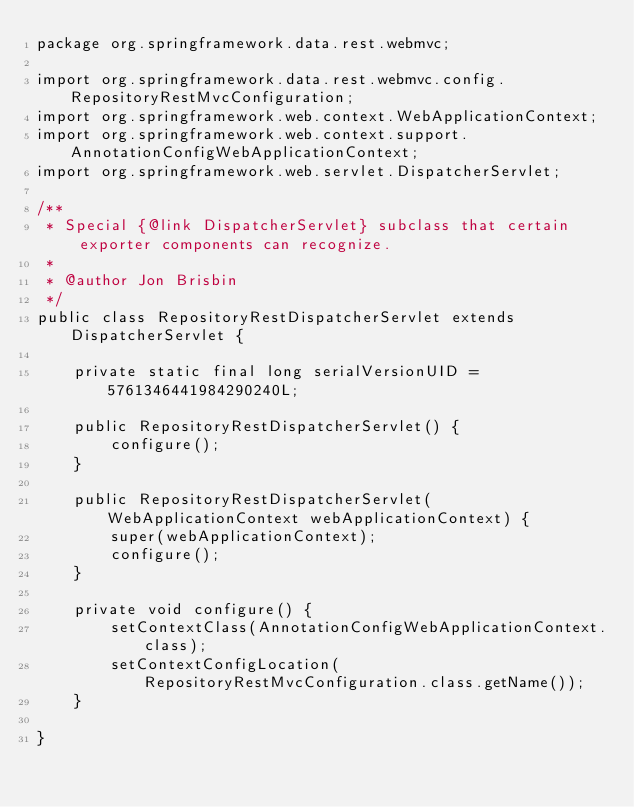Convert code to text. <code><loc_0><loc_0><loc_500><loc_500><_Java_>package org.springframework.data.rest.webmvc;

import org.springframework.data.rest.webmvc.config.RepositoryRestMvcConfiguration;
import org.springframework.web.context.WebApplicationContext;
import org.springframework.web.context.support.AnnotationConfigWebApplicationContext;
import org.springframework.web.servlet.DispatcherServlet;

/**
 * Special {@link DispatcherServlet} subclass that certain exporter components can recognize.
 * 
 * @author Jon Brisbin
 */
public class RepositoryRestDispatcherServlet extends DispatcherServlet {

	private static final long serialVersionUID = 5761346441984290240L;

	public RepositoryRestDispatcherServlet() {
		configure();
	}

	public RepositoryRestDispatcherServlet(WebApplicationContext webApplicationContext) {
		super(webApplicationContext);
		configure();
	}

	private void configure() {
		setContextClass(AnnotationConfigWebApplicationContext.class);
		setContextConfigLocation(RepositoryRestMvcConfiguration.class.getName());
	}

}
</code> 